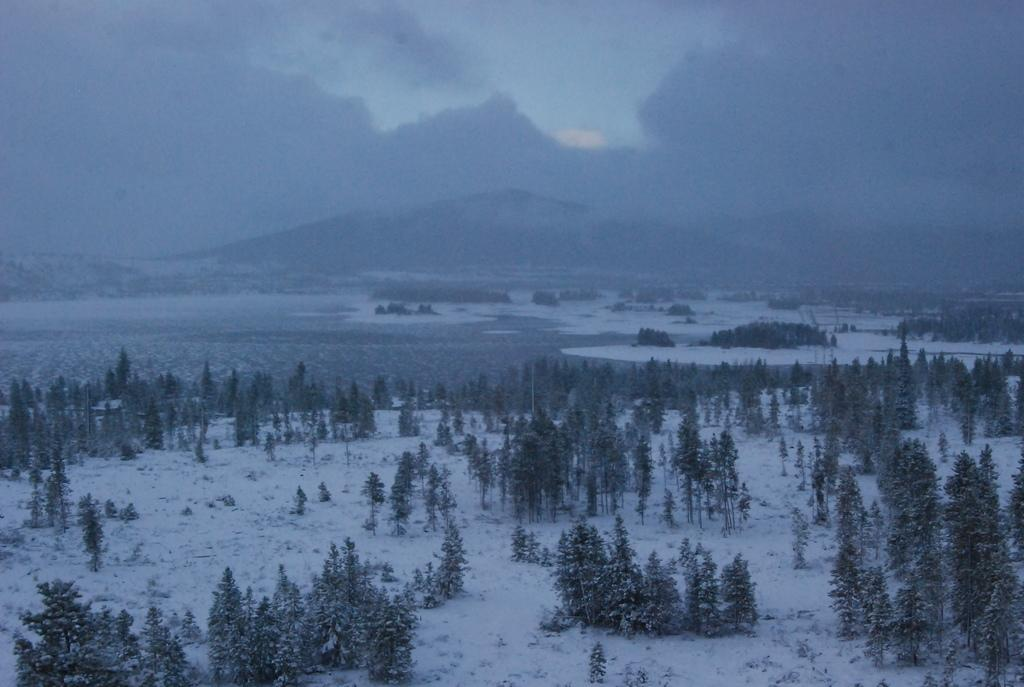What type of vegetation can be seen in the image? There are trees in the image. What can be seen in the sky in the image? There are clouds in the image. What is visible in the background of the image? The sky is visible in the image. What is the ground covered with in the image? There is snow on the ground in the image. What song is being sung by the trees in the image? There is no indication in the image that the trees are singing a song. What type of root system do the trees have in the image? The image does not show the root system of the trees, so it cannot be determined from the image. 